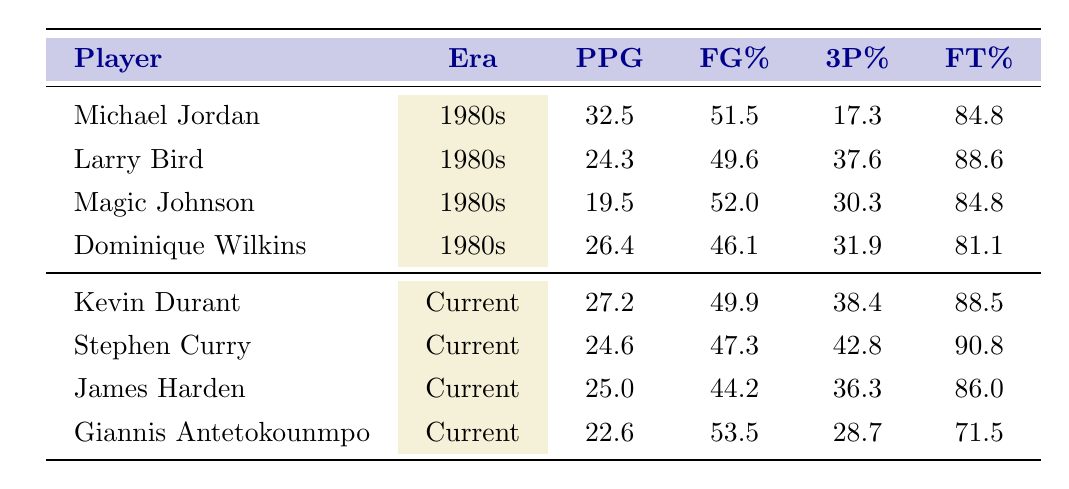What is Michael Jordan's points per game average? Michael Jordan's row in the table indicates he scored an average of 32.5 points per game during the 1980s.
Answer: 32.5 Which player had the highest field goal percentage in the 1980s? By looking at the field goal percentage column for the 1980s players, I see that Magic Johnson has the highest field goal percentage at 52.0%.
Answer: Magic Johnson What is the average points per game for current NBA stars listed? To find the average, I sum the points per game for the current players: 27.2 + 24.6 + 25.0 + 22.6 = 99.4. There are 4 players, so the average is 99.4 / 4 = 24.85.
Answer: 24.85 Did Larry Bird have a higher free throw percentage than Giannis Antetokounmpo? Larry Bird's free throw percentage of 88.6% is compared to Giannis Antetokounmpo's percentage of 71.5%. Since 88.6% is greater than 71.5%, the answer is yes.
Answer: Yes What is the combined points per game of all the players from the 1980s? I add the points per game for all four 1980s players: 32.5 + 24.3 + 19.5 + 26.4 = 102.7.
Answer: 102.7 Which player has the best 3-point shooting percentage in the current NBA, and what is that percentage? In the current players' section, Stephen Curry has the highest 3-point percentage at 42.8%.
Answer: Stephen Curry, 42.8% Is it true that Dominique Wilkins scored more points per game than James Harden? Dominique Wilkins has a points per game average of 26.4 and James Harden has 25.0. Since 26.4 is greater than 25.0, the statement is true.
Answer: True Between the two eras, which player has the highest points per game, and what is the value? Michael Jordan, from the 1980s, had the highest points per game at 32.5 compared to the highest current player, who is Kevin Durant at 27.2.
Answer: Michael Jordan, 32.5 